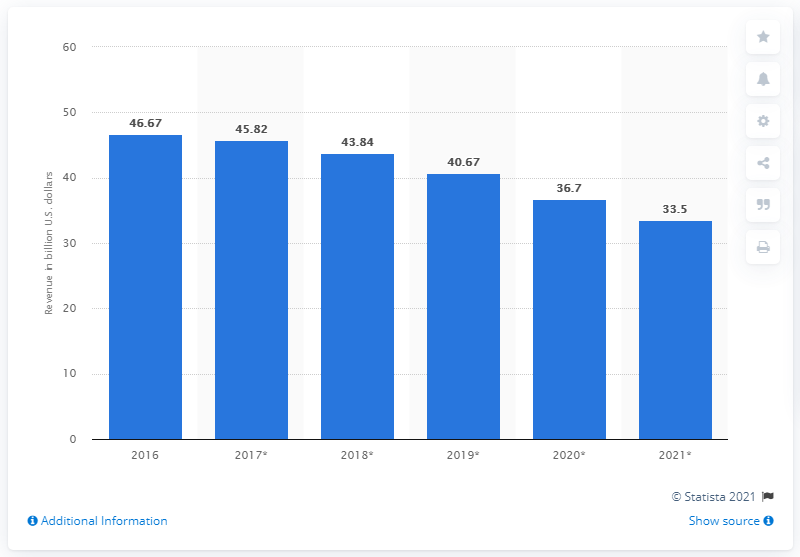Give some essential details in this illustration. In 2016, the global self-paced online learning market generated approximately 46.67 revenue. In 2021, the projected revenue of the global self-paced online learning market is expected to be approximately 33.5 billion US dollars. 